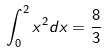<formula> <loc_0><loc_0><loc_500><loc_500>\int _ { 0 } ^ { 2 } x ^ { 2 } d x = \frac { 8 } { 3 }</formula> 